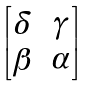<formula> <loc_0><loc_0><loc_500><loc_500>\begin{bmatrix} \delta & \gamma \\ \beta & \alpha \end{bmatrix}</formula> 